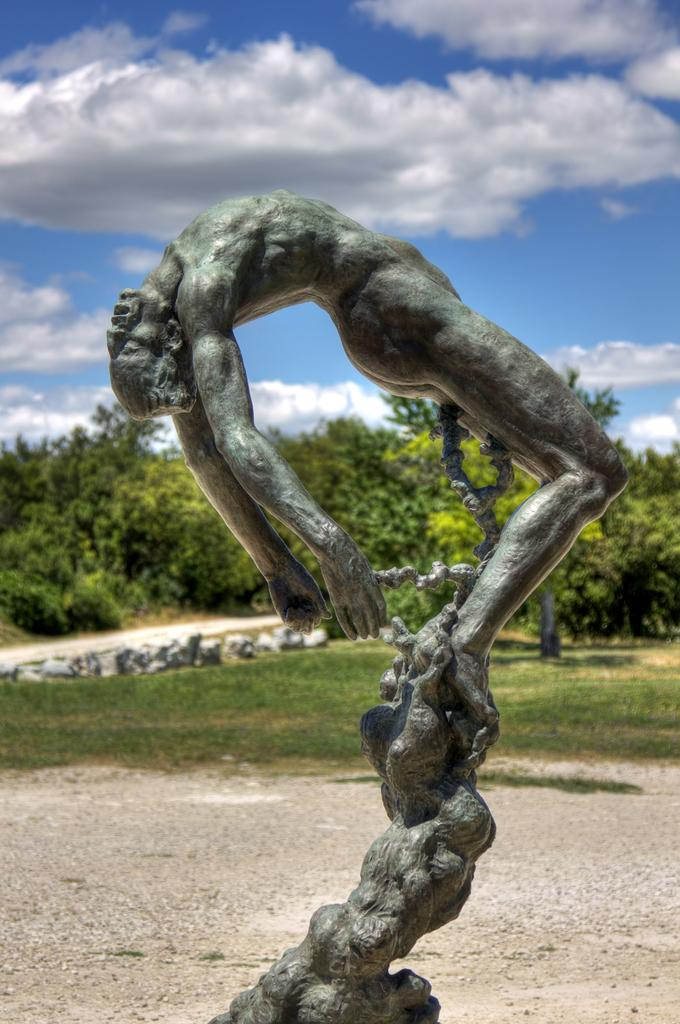What is the main subject in the front of the image? There is a statue in the front of the image. What type of vegetation is present in the front of the image? There is grass in the front of the image. What can be seen in the background of the image? There are trees in the background of the image. What is visible at the top of the image? The sky is visible at the top of the image. What is the condition of the sky in the image? Clouds are present in the sky. Can you tell me how many scissors are depicted in the image? There are no scissors present in the image. What type of toad can be seen sitting on the statue in the image? There is no toad present in the image; it only features a statue and the surrounding environment. 